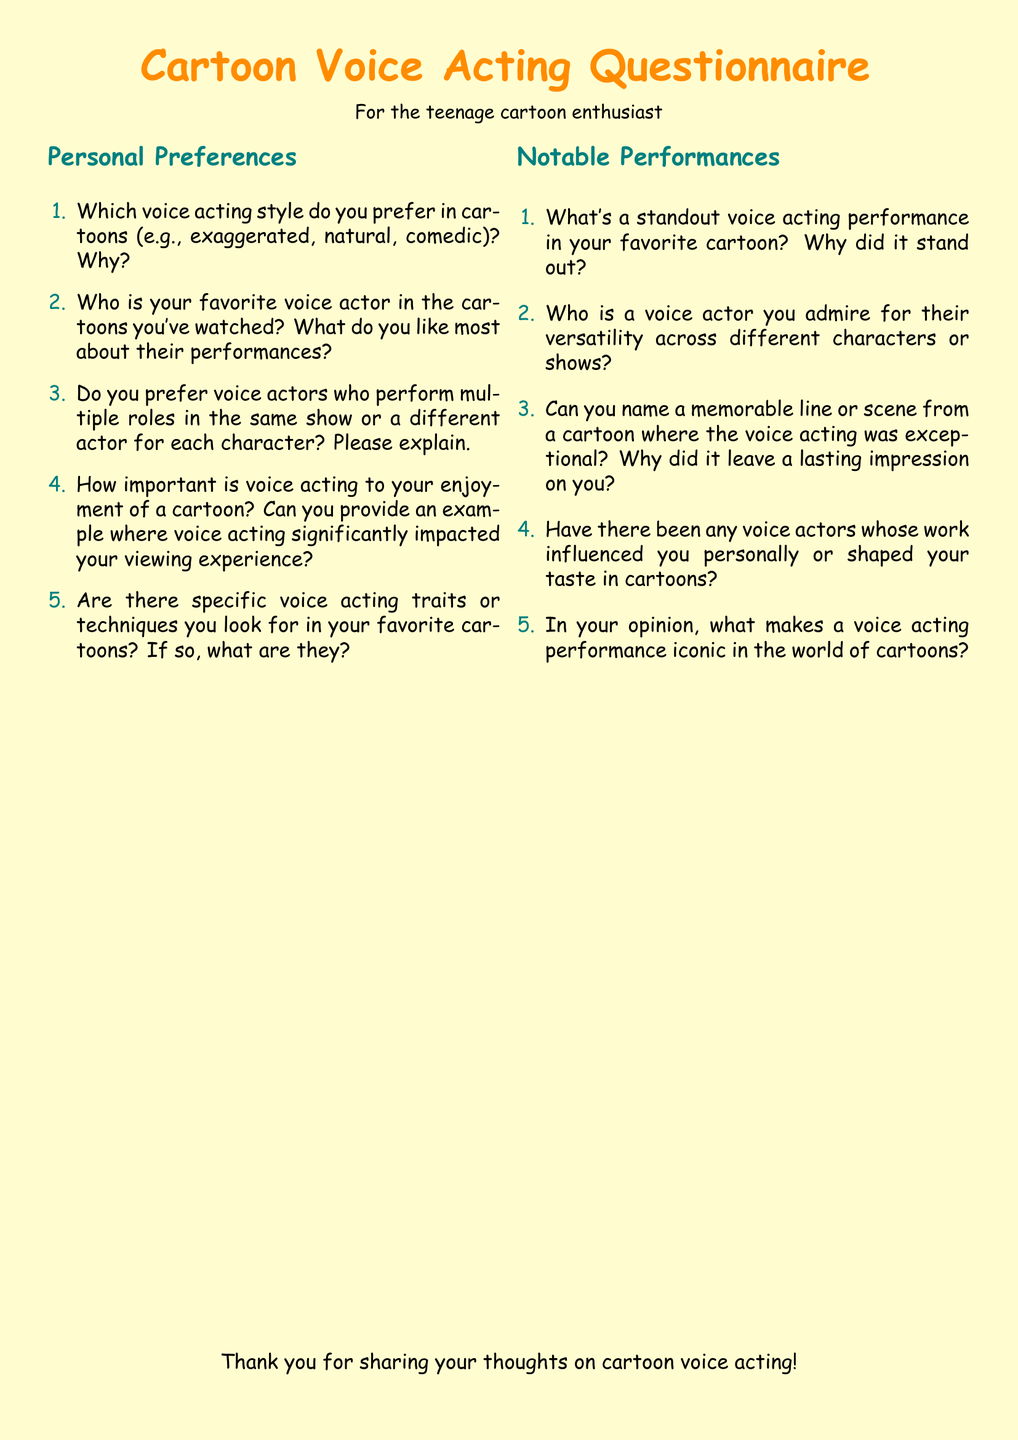Which font is used in the document? The font used throughout the document is specified in the code, which is Comic Sans MS.
Answer: Comic Sans MS What color is the background of the document? The background color is defined as RGB values, which correspond to a light color used throughout the document.
Answer: RGB(255,253,208) What is the main title of the questionnaire? The title of the questionnaire is prominently displayed at the top of the document.
Answer: Cartoon Voice Acting Questionnaire How many sections are there in the document? The document has a total of two main sections, as specified in the structure of the content.
Answer: 2 What is the first question under Personal Preferences? The first question listed under the Personal Preferences section is important for the viewer's input.
Answer: Which voice acting style do you prefer in cartoons (e.g., exaggerated, natural, comedic)? Why? What color is used for category titles? The color used for the section titles is important for visual distinction in the document.
Answer: RGB(0,128,128) Which target audience is indicated for the questionnaire? The intended audience is specified at the beginning, indicating who the questionnaire is designed for.
Answer: teenage cartoon enthusiast What is one of the topics covered under Notable Performances? The second section includes various important topics related to voice acting performance.
Answer: standout voice acting performance in your favorite cartoon What is the closing statement in the document? The closing statement provides appreciation for the reader's input, which characterizes the document's conclusion.
Answer: Thank you for sharing your thoughts on cartoon voice acting! 